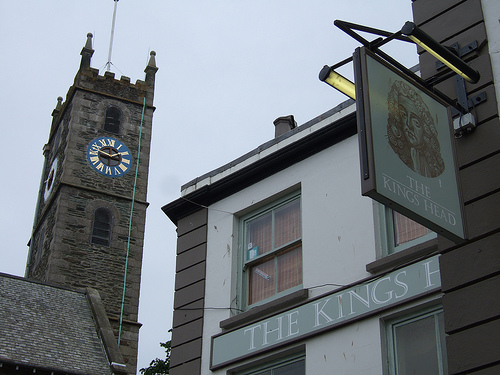Do you see any large buses or words? Yes, both elements are present. There is a large bus to the left, mostly outside the frame, and words displayed prominently on the sign of the 'King's Head' pub. 